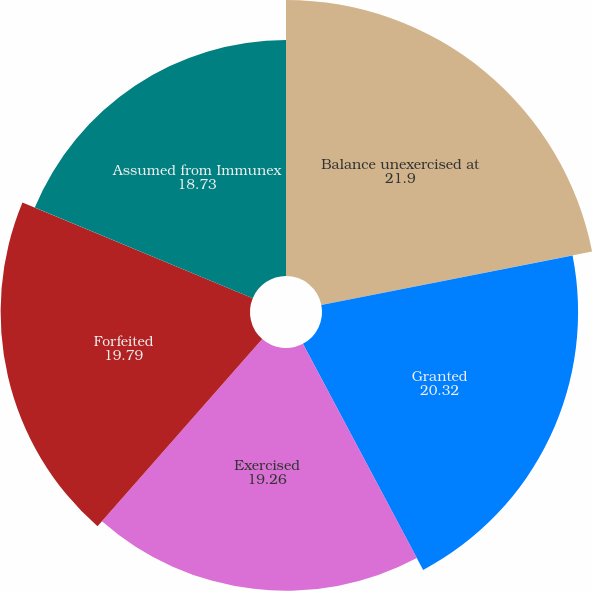Convert chart to OTSL. <chart><loc_0><loc_0><loc_500><loc_500><pie_chart><fcel>Balance unexercised at<fcel>Granted<fcel>Exercised<fcel>Forfeited<fcel>Assumed from Immunex<nl><fcel>21.9%<fcel>20.32%<fcel>19.26%<fcel>19.79%<fcel>18.73%<nl></chart> 